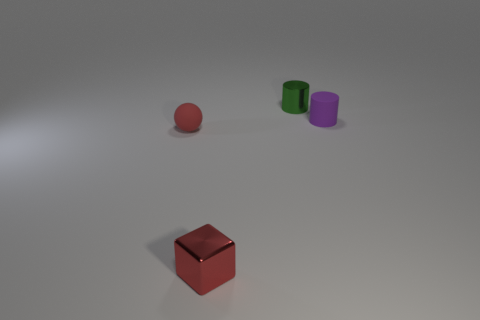Add 4 small red things. How many objects exist? 8 Subtract all blocks. How many objects are left? 3 Add 3 small cylinders. How many small cylinders exist? 5 Subtract 0 purple spheres. How many objects are left? 4 Subtract all gray matte cylinders. Subtract all rubber things. How many objects are left? 2 Add 4 purple matte cylinders. How many purple matte cylinders are left? 5 